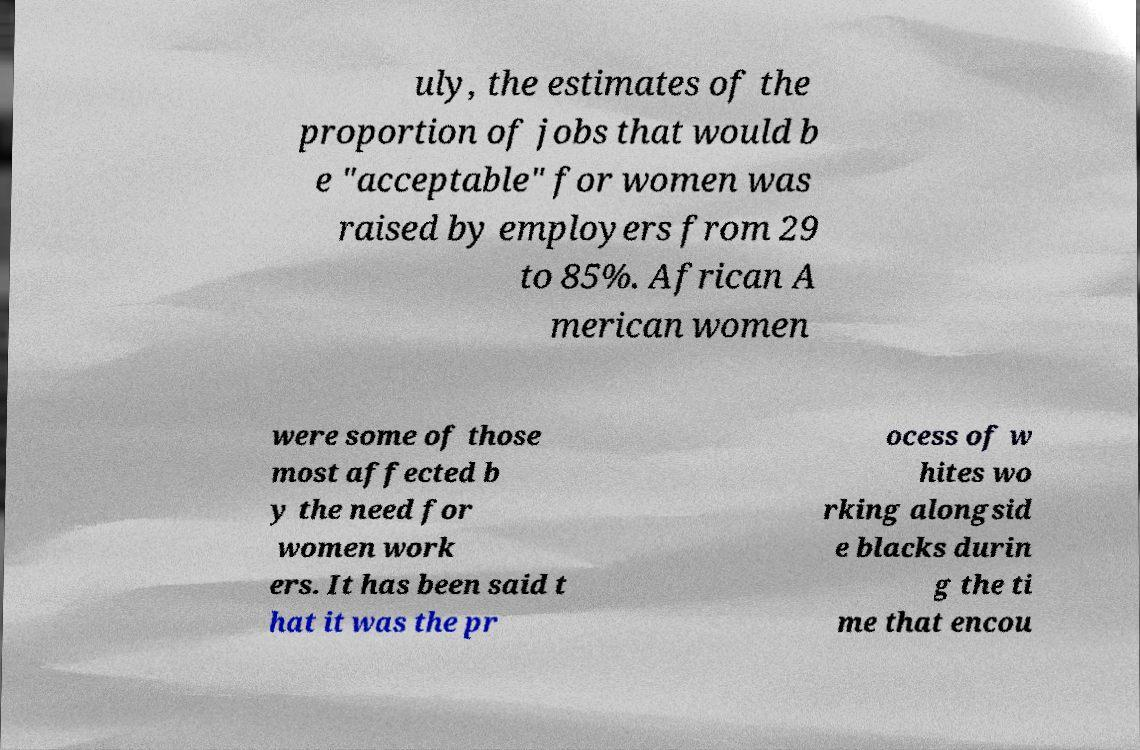I need the written content from this picture converted into text. Can you do that? uly, the estimates of the proportion of jobs that would b e "acceptable" for women was raised by employers from 29 to 85%. African A merican women were some of those most affected b y the need for women work ers. It has been said t hat it was the pr ocess of w hites wo rking alongsid e blacks durin g the ti me that encou 